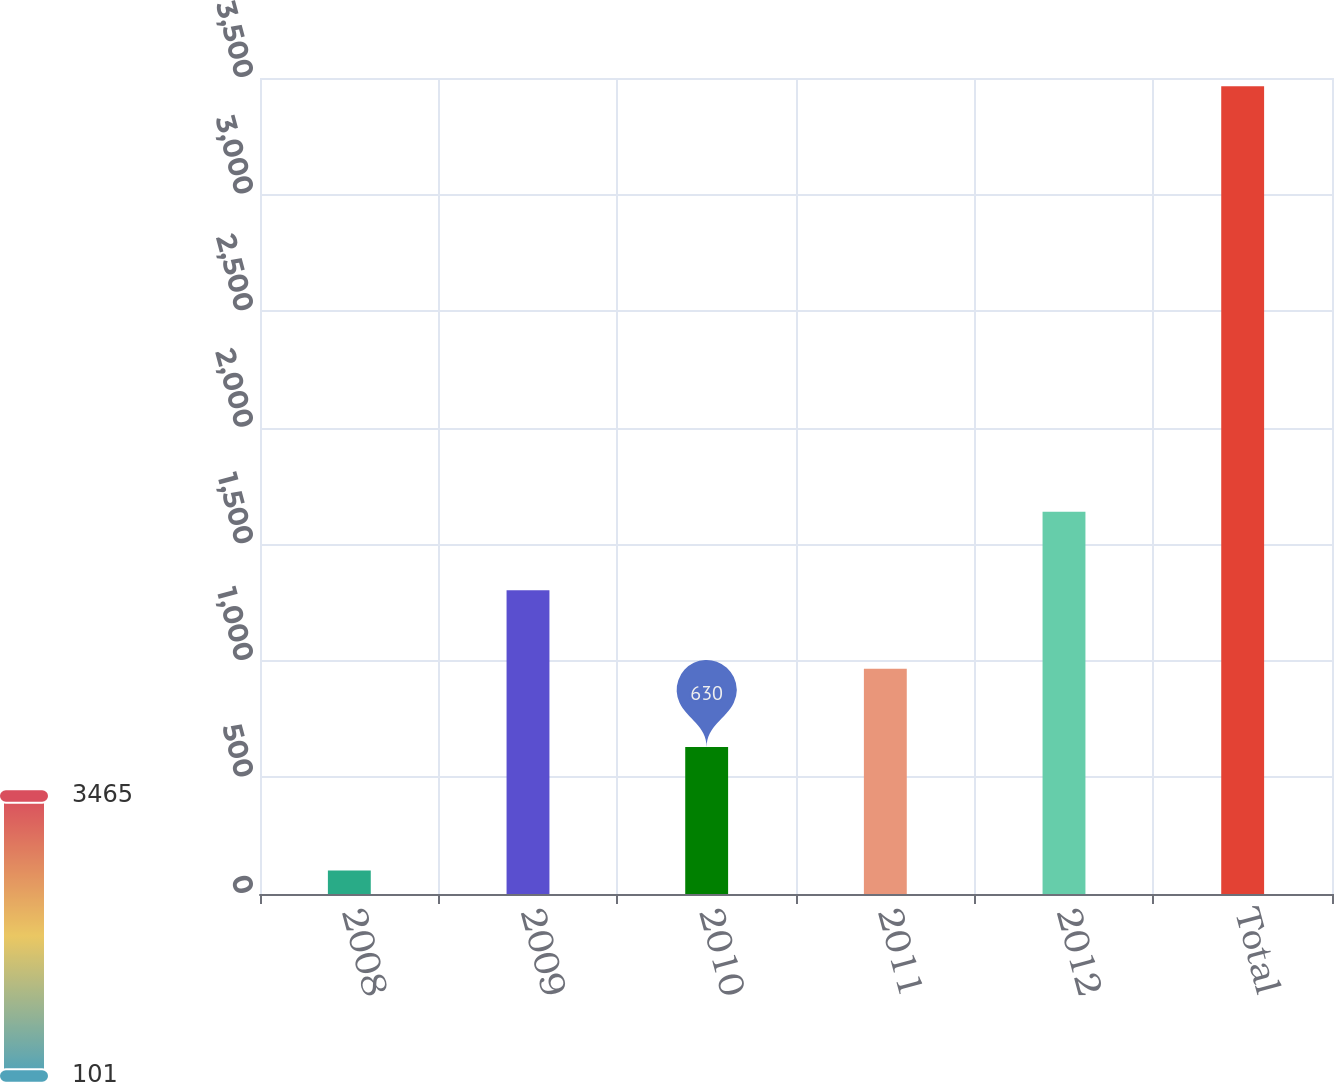Convert chart. <chart><loc_0><loc_0><loc_500><loc_500><bar_chart><fcel>2008<fcel>2009<fcel>2010<fcel>2011<fcel>2012<fcel>Total<nl><fcel>101<fcel>1302.8<fcel>630<fcel>966.4<fcel>1639.2<fcel>3465<nl></chart> 